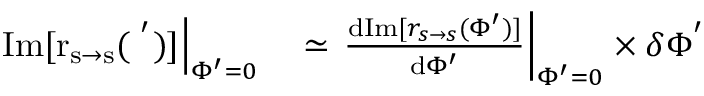<formula> <loc_0><loc_0><loc_500><loc_500>\begin{array} { r l } { I m [ r _ { s \rightarrow s } ( \Phi ^ { ^ { \prime } } ) ] \right | _ { \Phi ^ { \prime } = 0 } } & \simeq \frac { d I m [ r _ { s \rightarrow s } ( \Phi ^ { \prime } ) ] } { d \Phi ^ { \prime } } \right | _ { \Phi ^ { \prime } = 0 } \times \delta \Phi ^ { ^ { \prime } } } \end{array}</formula> 